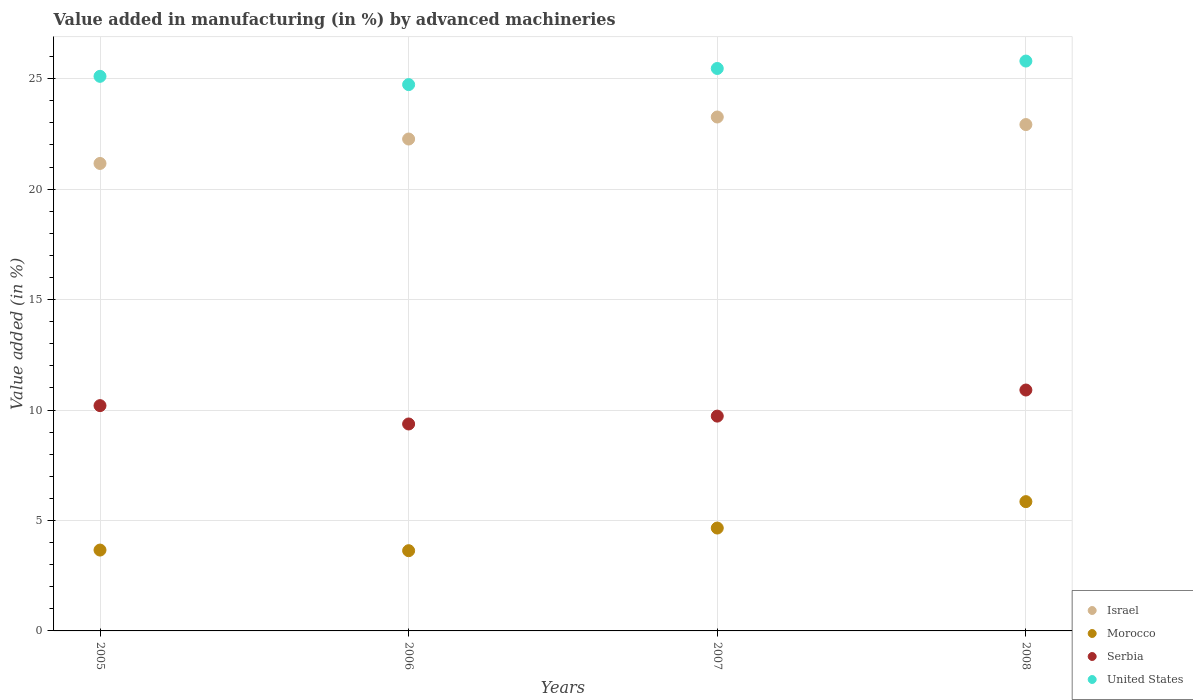How many different coloured dotlines are there?
Your answer should be very brief. 4. What is the percentage of value added in manufacturing by advanced machineries in Serbia in 2008?
Make the answer very short. 10.91. Across all years, what is the maximum percentage of value added in manufacturing by advanced machineries in Israel?
Offer a terse response. 23.26. Across all years, what is the minimum percentage of value added in manufacturing by advanced machineries in Serbia?
Your response must be concise. 9.37. In which year was the percentage of value added in manufacturing by advanced machineries in Israel maximum?
Offer a terse response. 2007. What is the total percentage of value added in manufacturing by advanced machineries in United States in the graph?
Ensure brevity in your answer.  101.09. What is the difference between the percentage of value added in manufacturing by advanced machineries in Serbia in 2007 and that in 2008?
Provide a succinct answer. -1.18. What is the difference between the percentage of value added in manufacturing by advanced machineries in Israel in 2007 and the percentage of value added in manufacturing by advanced machineries in Morocco in 2008?
Offer a very short reply. 17.41. What is the average percentage of value added in manufacturing by advanced machineries in Serbia per year?
Provide a short and direct response. 10.05. In the year 2006, what is the difference between the percentage of value added in manufacturing by advanced machineries in United States and percentage of value added in manufacturing by advanced machineries in Serbia?
Ensure brevity in your answer.  15.36. What is the ratio of the percentage of value added in manufacturing by advanced machineries in Morocco in 2005 to that in 2006?
Your response must be concise. 1.01. What is the difference between the highest and the second highest percentage of value added in manufacturing by advanced machineries in Morocco?
Your answer should be compact. 1.2. What is the difference between the highest and the lowest percentage of value added in manufacturing by advanced machineries in Serbia?
Make the answer very short. 1.54. In how many years, is the percentage of value added in manufacturing by advanced machineries in Israel greater than the average percentage of value added in manufacturing by advanced machineries in Israel taken over all years?
Provide a succinct answer. 2. Is it the case that in every year, the sum of the percentage of value added in manufacturing by advanced machineries in Morocco and percentage of value added in manufacturing by advanced machineries in Serbia  is greater than the sum of percentage of value added in manufacturing by advanced machineries in United States and percentage of value added in manufacturing by advanced machineries in Israel?
Offer a terse response. No. Does the percentage of value added in manufacturing by advanced machineries in Serbia monotonically increase over the years?
Provide a succinct answer. No. How many years are there in the graph?
Give a very brief answer. 4. Are the values on the major ticks of Y-axis written in scientific E-notation?
Provide a short and direct response. No. Does the graph contain any zero values?
Keep it short and to the point. No. Does the graph contain grids?
Your answer should be very brief. Yes. Where does the legend appear in the graph?
Your response must be concise. Bottom right. How many legend labels are there?
Give a very brief answer. 4. What is the title of the graph?
Ensure brevity in your answer.  Value added in manufacturing (in %) by advanced machineries. Does "Barbados" appear as one of the legend labels in the graph?
Give a very brief answer. No. What is the label or title of the X-axis?
Your answer should be compact. Years. What is the label or title of the Y-axis?
Your answer should be compact. Value added (in %). What is the Value added (in %) in Israel in 2005?
Offer a terse response. 21.16. What is the Value added (in %) in Morocco in 2005?
Provide a succinct answer. 3.66. What is the Value added (in %) in Serbia in 2005?
Your answer should be compact. 10.2. What is the Value added (in %) of United States in 2005?
Provide a short and direct response. 25.1. What is the Value added (in %) in Israel in 2006?
Make the answer very short. 22.27. What is the Value added (in %) in Morocco in 2006?
Give a very brief answer. 3.63. What is the Value added (in %) in Serbia in 2006?
Offer a very short reply. 9.37. What is the Value added (in %) in United States in 2006?
Give a very brief answer. 24.73. What is the Value added (in %) in Israel in 2007?
Ensure brevity in your answer.  23.26. What is the Value added (in %) of Morocco in 2007?
Your answer should be compact. 4.66. What is the Value added (in %) of Serbia in 2007?
Offer a very short reply. 9.72. What is the Value added (in %) of United States in 2007?
Make the answer very short. 25.46. What is the Value added (in %) of Israel in 2008?
Offer a terse response. 22.92. What is the Value added (in %) in Morocco in 2008?
Offer a terse response. 5.85. What is the Value added (in %) of Serbia in 2008?
Offer a terse response. 10.91. What is the Value added (in %) of United States in 2008?
Ensure brevity in your answer.  25.8. Across all years, what is the maximum Value added (in %) in Israel?
Your answer should be very brief. 23.26. Across all years, what is the maximum Value added (in %) in Morocco?
Your response must be concise. 5.85. Across all years, what is the maximum Value added (in %) of Serbia?
Your answer should be very brief. 10.91. Across all years, what is the maximum Value added (in %) in United States?
Your answer should be compact. 25.8. Across all years, what is the minimum Value added (in %) in Israel?
Give a very brief answer. 21.16. Across all years, what is the minimum Value added (in %) in Morocco?
Your answer should be very brief. 3.63. Across all years, what is the minimum Value added (in %) of Serbia?
Provide a succinct answer. 9.37. Across all years, what is the minimum Value added (in %) in United States?
Make the answer very short. 24.73. What is the total Value added (in %) of Israel in the graph?
Ensure brevity in your answer.  89.61. What is the total Value added (in %) of Morocco in the graph?
Offer a terse response. 17.8. What is the total Value added (in %) of Serbia in the graph?
Provide a short and direct response. 40.2. What is the total Value added (in %) in United States in the graph?
Ensure brevity in your answer.  101.09. What is the difference between the Value added (in %) in Israel in 2005 and that in 2006?
Your response must be concise. -1.11. What is the difference between the Value added (in %) of Morocco in 2005 and that in 2006?
Offer a terse response. 0.03. What is the difference between the Value added (in %) of Serbia in 2005 and that in 2006?
Make the answer very short. 0.83. What is the difference between the Value added (in %) in United States in 2005 and that in 2006?
Keep it short and to the point. 0.37. What is the difference between the Value added (in %) in Israel in 2005 and that in 2007?
Make the answer very short. -2.1. What is the difference between the Value added (in %) of Morocco in 2005 and that in 2007?
Offer a very short reply. -1. What is the difference between the Value added (in %) in Serbia in 2005 and that in 2007?
Keep it short and to the point. 0.47. What is the difference between the Value added (in %) of United States in 2005 and that in 2007?
Offer a terse response. -0.36. What is the difference between the Value added (in %) of Israel in 2005 and that in 2008?
Ensure brevity in your answer.  -1.76. What is the difference between the Value added (in %) in Morocco in 2005 and that in 2008?
Offer a terse response. -2.19. What is the difference between the Value added (in %) in Serbia in 2005 and that in 2008?
Provide a short and direct response. -0.71. What is the difference between the Value added (in %) of United States in 2005 and that in 2008?
Your answer should be very brief. -0.69. What is the difference between the Value added (in %) in Israel in 2006 and that in 2007?
Your response must be concise. -1. What is the difference between the Value added (in %) in Morocco in 2006 and that in 2007?
Provide a short and direct response. -1.03. What is the difference between the Value added (in %) of Serbia in 2006 and that in 2007?
Give a very brief answer. -0.36. What is the difference between the Value added (in %) in United States in 2006 and that in 2007?
Make the answer very short. -0.73. What is the difference between the Value added (in %) of Israel in 2006 and that in 2008?
Ensure brevity in your answer.  -0.65. What is the difference between the Value added (in %) of Morocco in 2006 and that in 2008?
Provide a succinct answer. -2.22. What is the difference between the Value added (in %) of Serbia in 2006 and that in 2008?
Your response must be concise. -1.54. What is the difference between the Value added (in %) of United States in 2006 and that in 2008?
Your answer should be very brief. -1.07. What is the difference between the Value added (in %) of Israel in 2007 and that in 2008?
Offer a terse response. 0.34. What is the difference between the Value added (in %) of Morocco in 2007 and that in 2008?
Make the answer very short. -1.2. What is the difference between the Value added (in %) in Serbia in 2007 and that in 2008?
Offer a terse response. -1.18. What is the difference between the Value added (in %) in United States in 2007 and that in 2008?
Offer a terse response. -0.34. What is the difference between the Value added (in %) in Israel in 2005 and the Value added (in %) in Morocco in 2006?
Offer a very short reply. 17.53. What is the difference between the Value added (in %) in Israel in 2005 and the Value added (in %) in Serbia in 2006?
Provide a succinct answer. 11.79. What is the difference between the Value added (in %) of Israel in 2005 and the Value added (in %) of United States in 2006?
Provide a succinct answer. -3.57. What is the difference between the Value added (in %) in Morocco in 2005 and the Value added (in %) in Serbia in 2006?
Your response must be concise. -5.71. What is the difference between the Value added (in %) of Morocco in 2005 and the Value added (in %) of United States in 2006?
Provide a succinct answer. -21.07. What is the difference between the Value added (in %) in Serbia in 2005 and the Value added (in %) in United States in 2006?
Make the answer very short. -14.53. What is the difference between the Value added (in %) in Israel in 2005 and the Value added (in %) in Morocco in 2007?
Provide a short and direct response. 16.5. What is the difference between the Value added (in %) in Israel in 2005 and the Value added (in %) in Serbia in 2007?
Make the answer very short. 11.44. What is the difference between the Value added (in %) in Israel in 2005 and the Value added (in %) in United States in 2007?
Your answer should be very brief. -4.3. What is the difference between the Value added (in %) of Morocco in 2005 and the Value added (in %) of Serbia in 2007?
Your answer should be compact. -6.06. What is the difference between the Value added (in %) in Morocco in 2005 and the Value added (in %) in United States in 2007?
Offer a terse response. -21.8. What is the difference between the Value added (in %) in Serbia in 2005 and the Value added (in %) in United States in 2007?
Keep it short and to the point. -15.26. What is the difference between the Value added (in %) in Israel in 2005 and the Value added (in %) in Morocco in 2008?
Your response must be concise. 15.31. What is the difference between the Value added (in %) in Israel in 2005 and the Value added (in %) in Serbia in 2008?
Offer a terse response. 10.26. What is the difference between the Value added (in %) in Israel in 2005 and the Value added (in %) in United States in 2008?
Your answer should be very brief. -4.64. What is the difference between the Value added (in %) of Morocco in 2005 and the Value added (in %) of Serbia in 2008?
Ensure brevity in your answer.  -7.25. What is the difference between the Value added (in %) in Morocco in 2005 and the Value added (in %) in United States in 2008?
Your response must be concise. -22.14. What is the difference between the Value added (in %) of Serbia in 2005 and the Value added (in %) of United States in 2008?
Offer a very short reply. -15.6. What is the difference between the Value added (in %) of Israel in 2006 and the Value added (in %) of Morocco in 2007?
Your response must be concise. 17.61. What is the difference between the Value added (in %) in Israel in 2006 and the Value added (in %) in Serbia in 2007?
Offer a terse response. 12.54. What is the difference between the Value added (in %) of Israel in 2006 and the Value added (in %) of United States in 2007?
Offer a terse response. -3.19. What is the difference between the Value added (in %) in Morocco in 2006 and the Value added (in %) in Serbia in 2007?
Keep it short and to the point. -6.09. What is the difference between the Value added (in %) of Morocco in 2006 and the Value added (in %) of United States in 2007?
Your answer should be very brief. -21.83. What is the difference between the Value added (in %) in Serbia in 2006 and the Value added (in %) in United States in 2007?
Make the answer very short. -16.09. What is the difference between the Value added (in %) in Israel in 2006 and the Value added (in %) in Morocco in 2008?
Make the answer very short. 16.41. What is the difference between the Value added (in %) in Israel in 2006 and the Value added (in %) in Serbia in 2008?
Make the answer very short. 11.36. What is the difference between the Value added (in %) of Israel in 2006 and the Value added (in %) of United States in 2008?
Offer a terse response. -3.53. What is the difference between the Value added (in %) of Morocco in 2006 and the Value added (in %) of Serbia in 2008?
Your response must be concise. -7.27. What is the difference between the Value added (in %) of Morocco in 2006 and the Value added (in %) of United States in 2008?
Offer a very short reply. -22.16. What is the difference between the Value added (in %) in Serbia in 2006 and the Value added (in %) in United States in 2008?
Give a very brief answer. -16.43. What is the difference between the Value added (in %) of Israel in 2007 and the Value added (in %) of Morocco in 2008?
Provide a succinct answer. 17.41. What is the difference between the Value added (in %) in Israel in 2007 and the Value added (in %) in Serbia in 2008?
Your response must be concise. 12.36. What is the difference between the Value added (in %) in Israel in 2007 and the Value added (in %) in United States in 2008?
Give a very brief answer. -2.53. What is the difference between the Value added (in %) in Morocco in 2007 and the Value added (in %) in Serbia in 2008?
Provide a succinct answer. -6.25. What is the difference between the Value added (in %) in Morocco in 2007 and the Value added (in %) in United States in 2008?
Make the answer very short. -21.14. What is the difference between the Value added (in %) in Serbia in 2007 and the Value added (in %) in United States in 2008?
Make the answer very short. -16.07. What is the average Value added (in %) in Israel per year?
Keep it short and to the point. 22.4. What is the average Value added (in %) of Morocco per year?
Your answer should be very brief. 4.45. What is the average Value added (in %) of Serbia per year?
Your answer should be very brief. 10.05. What is the average Value added (in %) of United States per year?
Keep it short and to the point. 25.27. In the year 2005, what is the difference between the Value added (in %) in Israel and Value added (in %) in Morocco?
Your answer should be compact. 17.5. In the year 2005, what is the difference between the Value added (in %) of Israel and Value added (in %) of Serbia?
Ensure brevity in your answer.  10.96. In the year 2005, what is the difference between the Value added (in %) of Israel and Value added (in %) of United States?
Offer a very short reply. -3.94. In the year 2005, what is the difference between the Value added (in %) in Morocco and Value added (in %) in Serbia?
Keep it short and to the point. -6.54. In the year 2005, what is the difference between the Value added (in %) in Morocco and Value added (in %) in United States?
Give a very brief answer. -21.44. In the year 2005, what is the difference between the Value added (in %) in Serbia and Value added (in %) in United States?
Provide a succinct answer. -14.91. In the year 2006, what is the difference between the Value added (in %) of Israel and Value added (in %) of Morocco?
Your answer should be compact. 18.64. In the year 2006, what is the difference between the Value added (in %) of Israel and Value added (in %) of Serbia?
Provide a short and direct response. 12.9. In the year 2006, what is the difference between the Value added (in %) in Israel and Value added (in %) in United States?
Offer a very short reply. -2.46. In the year 2006, what is the difference between the Value added (in %) of Morocco and Value added (in %) of Serbia?
Make the answer very short. -5.74. In the year 2006, what is the difference between the Value added (in %) in Morocco and Value added (in %) in United States?
Your answer should be very brief. -21.1. In the year 2006, what is the difference between the Value added (in %) in Serbia and Value added (in %) in United States?
Your answer should be compact. -15.36. In the year 2007, what is the difference between the Value added (in %) of Israel and Value added (in %) of Morocco?
Your answer should be compact. 18.61. In the year 2007, what is the difference between the Value added (in %) of Israel and Value added (in %) of Serbia?
Keep it short and to the point. 13.54. In the year 2007, what is the difference between the Value added (in %) in Israel and Value added (in %) in United States?
Give a very brief answer. -2.2. In the year 2007, what is the difference between the Value added (in %) in Morocco and Value added (in %) in Serbia?
Your answer should be very brief. -5.07. In the year 2007, what is the difference between the Value added (in %) of Morocco and Value added (in %) of United States?
Offer a very short reply. -20.8. In the year 2007, what is the difference between the Value added (in %) in Serbia and Value added (in %) in United States?
Your answer should be very brief. -15.74. In the year 2008, what is the difference between the Value added (in %) of Israel and Value added (in %) of Morocco?
Make the answer very short. 17.07. In the year 2008, what is the difference between the Value added (in %) of Israel and Value added (in %) of Serbia?
Your answer should be very brief. 12.02. In the year 2008, what is the difference between the Value added (in %) in Israel and Value added (in %) in United States?
Your answer should be compact. -2.87. In the year 2008, what is the difference between the Value added (in %) in Morocco and Value added (in %) in Serbia?
Make the answer very short. -5.05. In the year 2008, what is the difference between the Value added (in %) of Morocco and Value added (in %) of United States?
Offer a very short reply. -19.94. In the year 2008, what is the difference between the Value added (in %) of Serbia and Value added (in %) of United States?
Offer a terse response. -14.89. What is the ratio of the Value added (in %) of Israel in 2005 to that in 2006?
Provide a succinct answer. 0.95. What is the ratio of the Value added (in %) in Serbia in 2005 to that in 2006?
Ensure brevity in your answer.  1.09. What is the ratio of the Value added (in %) of United States in 2005 to that in 2006?
Provide a succinct answer. 1.02. What is the ratio of the Value added (in %) in Israel in 2005 to that in 2007?
Offer a terse response. 0.91. What is the ratio of the Value added (in %) in Morocco in 2005 to that in 2007?
Provide a succinct answer. 0.79. What is the ratio of the Value added (in %) of Serbia in 2005 to that in 2007?
Offer a very short reply. 1.05. What is the ratio of the Value added (in %) in Israel in 2005 to that in 2008?
Offer a terse response. 0.92. What is the ratio of the Value added (in %) in Morocco in 2005 to that in 2008?
Provide a succinct answer. 0.63. What is the ratio of the Value added (in %) in Serbia in 2005 to that in 2008?
Offer a very short reply. 0.94. What is the ratio of the Value added (in %) in United States in 2005 to that in 2008?
Provide a short and direct response. 0.97. What is the ratio of the Value added (in %) in Israel in 2006 to that in 2007?
Keep it short and to the point. 0.96. What is the ratio of the Value added (in %) in Morocco in 2006 to that in 2007?
Make the answer very short. 0.78. What is the ratio of the Value added (in %) of Serbia in 2006 to that in 2007?
Your answer should be very brief. 0.96. What is the ratio of the Value added (in %) in United States in 2006 to that in 2007?
Give a very brief answer. 0.97. What is the ratio of the Value added (in %) in Israel in 2006 to that in 2008?
Your response must be concise. 0.97. What is the ratio of the Value added (in %) in Morocco in 2006 to that in 2008?
Keep it short and to the point. 0.62. What is the ratio of the Value added (in %) in Serbia in 2006 to that in 2008?
Your response must be concise. 0.86. What is the ratio of the Value added (in %) of United States in 2006 to that in 2008?
Make the answer very short. 0.96. What is the ratio of the Value added (in %) of Israel in 2007 to that in 2008?
Keep it short and to the point. 1.01. What is the ratio of the Value added (in %) in Morocco in 2007 to that in 2008?
Give a very brief answer. 0.8. What is the ratio of the Value added (in %) of Serbia in 2007 to that in 2008?
Provide a succinct answer. 0.89. What is the difference between the highest and the second highest Value added (in %) of Israel?
Offer a terse response. 0.34. What is the difference between the highest and the second highest Value added (in %) of Morocco?
Your answer should be very brief. 1.2. What is the difference between the highest and the second highest Value added (in %) in Serbia?
Offer a terse response. 0.71. What is the difference between the highest and the second highest Value added (in %) of United States?
Provide a short and direct response. 0.34. What is the difference between the highest and the lowest Value added (in %) in Israel?
Make the answer very short. 2.1. What is the difference between the highest and the lowest Value added (in %) of Morocco?
Your response must be concise. 2.22. What is the difference between the highest and the lowest Value added (in %) of Serbia?
Your answer should be compact. 1.54. What is the difference between the highest and the lowest Value added (in %) in United States?
Provide a succinct answer. 1.07. 